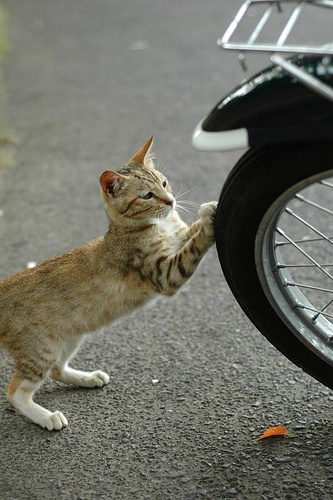Describe the objects in this image and their specific colors. I can see motorcycle in gray, black, darkgray, and lightgray tones, bicycle in gray, black, darkgray, and lightgray tones, and cat in gray and olive tones in this image. 